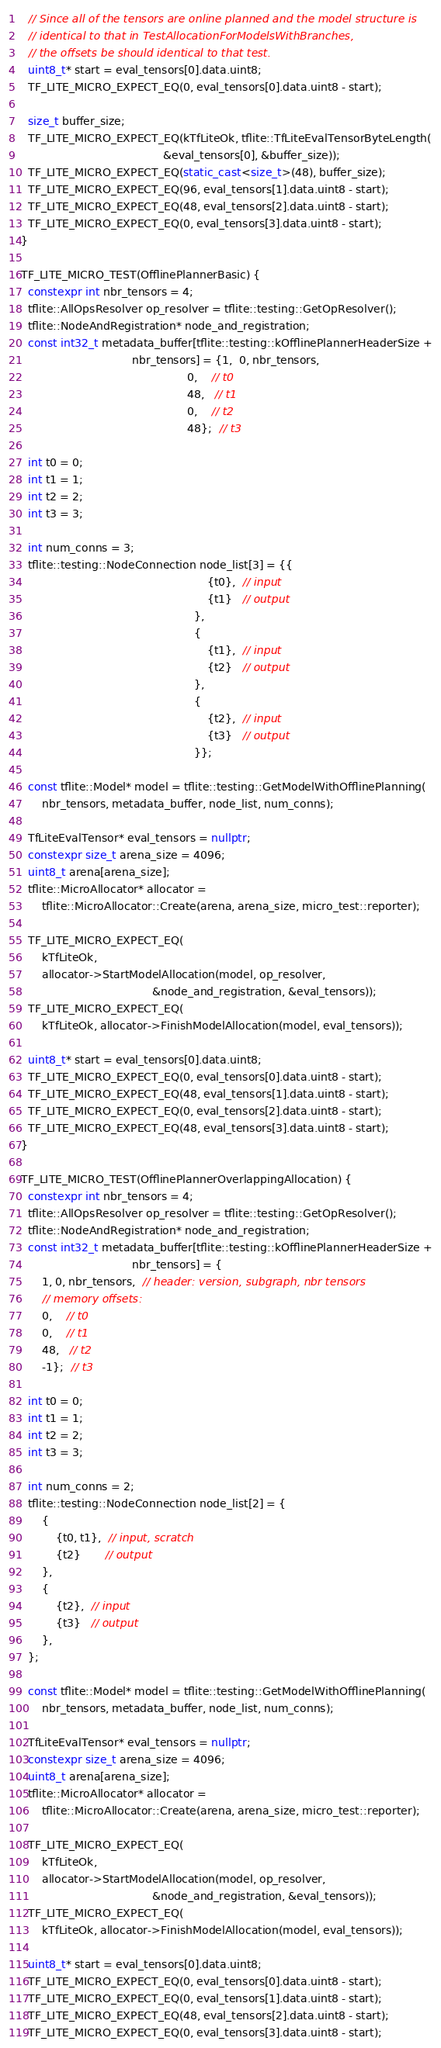Convert code to text. <code><loc_0><loc_0><loc_500><loc_500><_C++_>
  // Since all of the tensors are online planned and the model structure is
  // identical to that in TestAllocationForModelsWithBranches,
  // the offsets be should identical to that test.
  uint8_t* start = eval_tensors[0].data.uint8;
  TF_LITE_MICRO_EXPECT_EQ(0, eval_tensors[0].data.uint8 - start);

  size_t buffer_size;
  TF_LITE_MICRO_EXPECT_EQ(kTfLiteOk, tflite::TfLiteEvalTensorByteLength(
                                         &eval_tensors[0], &buffer_size));
  TF_LITE_MICRO_EXPECT_EQ(static_cast<size_t>(48), buffer_size);
  TF_LITE_MICRO_EXPECT_EQ(96, eval_tensors[1].data.uint8 - start);
  TF_LITE_MICRO_EXPECT_EQ(48, eval_tensors[2].data.uint8 - start);
  TF_LITE_MICRO_EXPECT_EQ(0, eval_tensors[3].data.uint8 - start);
}

TF_LITE_MICRO_TEST(OfflinePlannerBasic) {
  constexpr int nbr_tensors = 4;
  tflite::AllOpsResolver op_resolver = tflite::testing::GetOpResolver();
  tflite::NodeAndRegistration* node_and_registration;
  const int32_t metadata_buffer[tflite::testing::kOfflinePlannerHeaderSize +
                                nbr_tensors] = {1,  0, nbr_tensors,
                                                0,    // t0
                                                48,   // t1
                                                0,    // t2
                                                48};  // t3

  int t0 = 0;
  int t1 = 1;
  int t2 = 2;
  int t3 = 3;

  int num_conns = 3;
  tflite::testing::NodeConnection node_list[3] = {{
                                                      {t0},  // input
                                                      {t1}   // output
                                                  },
                                                  {
                                                      {t1},  // input
                                                      {t2}   // output
                                                  },
                                                  {
                                                      {t2},  // input
                                                      {t3}   // output
                                                  }};

  const tflite::Model* model = tflite::testing::GetModelWithOfflinePlanning(
      nbr_tensors, metadata_buffer, node_list, num_conns);

  TfLiteEvalTensor* eval_tensors = nullptr;
  constexpr size_t arena_size = 4096;
  uint8_t arena[arena_size];
  tflite::MicroAllocator* allocator =
      tflite::MicroAllocator::Create(arena, arena_size, micro_test::reporter);

  TF_LITE_MICRO_EXPECT_EQ(
      kTfLiteOk,
      allocator->StartModelAllocation(model, op_resolver,
                                      &node_and_registration, &eval_tensors));
  TF_LITE_MICRO_EXPECT_EQ(
      kTfLiteOk, allocator->FinishModelAllocation(model, eval_tensors));

  uint8_t* start = eval_tensors[0].data.uint8;
  TF_LITE_MICRO_EXPECT_EQ(0, eval_tensors[0].data.uint8 - start);
  TF_LITE_MICRO_EXPECT_EQ(48, eval_tensors[1].data.uint8 - start);
  TF_LITE_MICRO_EXPECT_EQ(0, eval_tensors[2].data.uint8 - start);
  TF_LITE_MICRO_EXPECT_EQ(48, eval_tensors[3].data.uint8 - start);
}

TF_LITE_MICRO_TEST(OfflinePlannerOverlappingAllocation) {
  constexpr int nbr_tensors = 4;
  tflite::AllOpsResolver op_resolver = tflite::testing::GetOpResolver();
  tflite::NodeAndRegistration* node_and_registration;
  const int32_t metadata_buffer[tflite::testing::kOfflinePlannerHeaderSize +
                                nbr_tensors] = {
      1, 0, nbr_tensors,  // header: version, subgraph, nbr tensors
      // memory offsets:
      0,    // t0
      0,    // t1
      48,   // t2
      -1};  // t3

  int t0 = 0;
  int t1 = 1;
  int t2 = 2;
  int t3 = 3;

  int num_conns = 2;
  tflite::testing::NodeConnection node_list[2] = {
      {
          {t0, t1},  // input, scratch
          {t2}       // output
      },
      {
          {t2},  // input
          {t3}   // output
      },
  };

  const tflite::Model* model = tflite::testing::GetModelWithOfflinePlanning(
      nbr_tensors, metadata_buffer, node_list, num_conns);

  TfLiteEvalTensor* eval_tensors = nullptr;
  constexpr size_t arena_size = 4096;
  uint8_t arena[arena_size];
  tflite::MicroAllocator* allocator =
      tflite::MicroAllocator::Create(arena, arena_size, micro_test::reporter);

  TF_LITE_MICRO_EXPECT_EQ(
      kTfLiteOk,
      allocator->StartModelAllocation(model, op_resolver,
                                      &node_and_registration, &eval_tensors));
  TF_LITE_MICRO_EXPECT_EQ(
      kTfLiteOk, allocator->FinishModelAllocation(model, eval_tensors));

  uint8_t* start = eval_tensors[0].data.uint8;
  TF_LITE_MICRO_EXPECT_EQ(0, eval_tensors[0].data.uint8 - start);
  TF_LITE_MICRO_EXPECT_EQ(0, eval_tensors[1].data.uint8 - start);
  TF_LITE_MICRO_EXPECT_EQ(48, eval_tensors[2].data.uint8 - start);
  TF_LITE_MICRO_EXPECT_EQ(0, eval_tensors[3].data.uint8 - start);</code> 